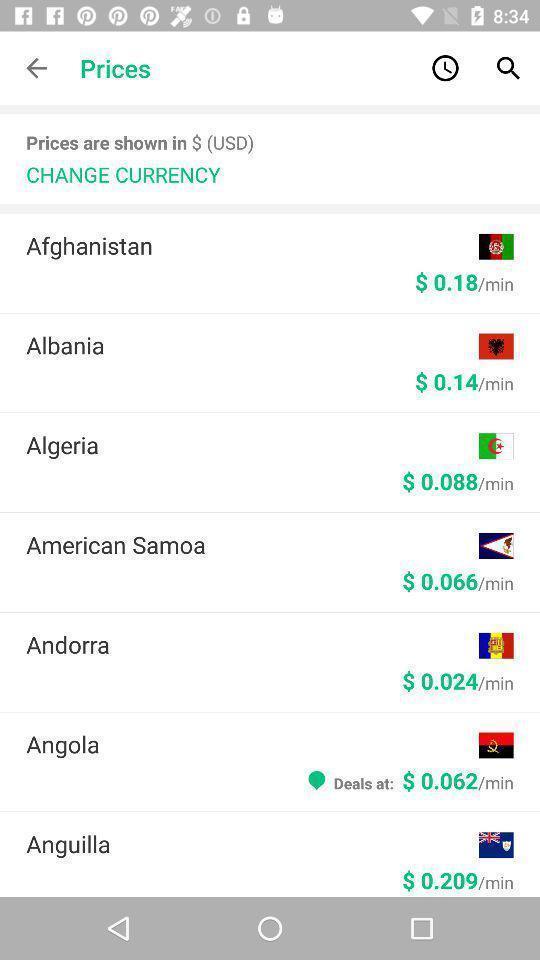Describe the visual elements of this screenshot. Page showing info in an international calling app. 